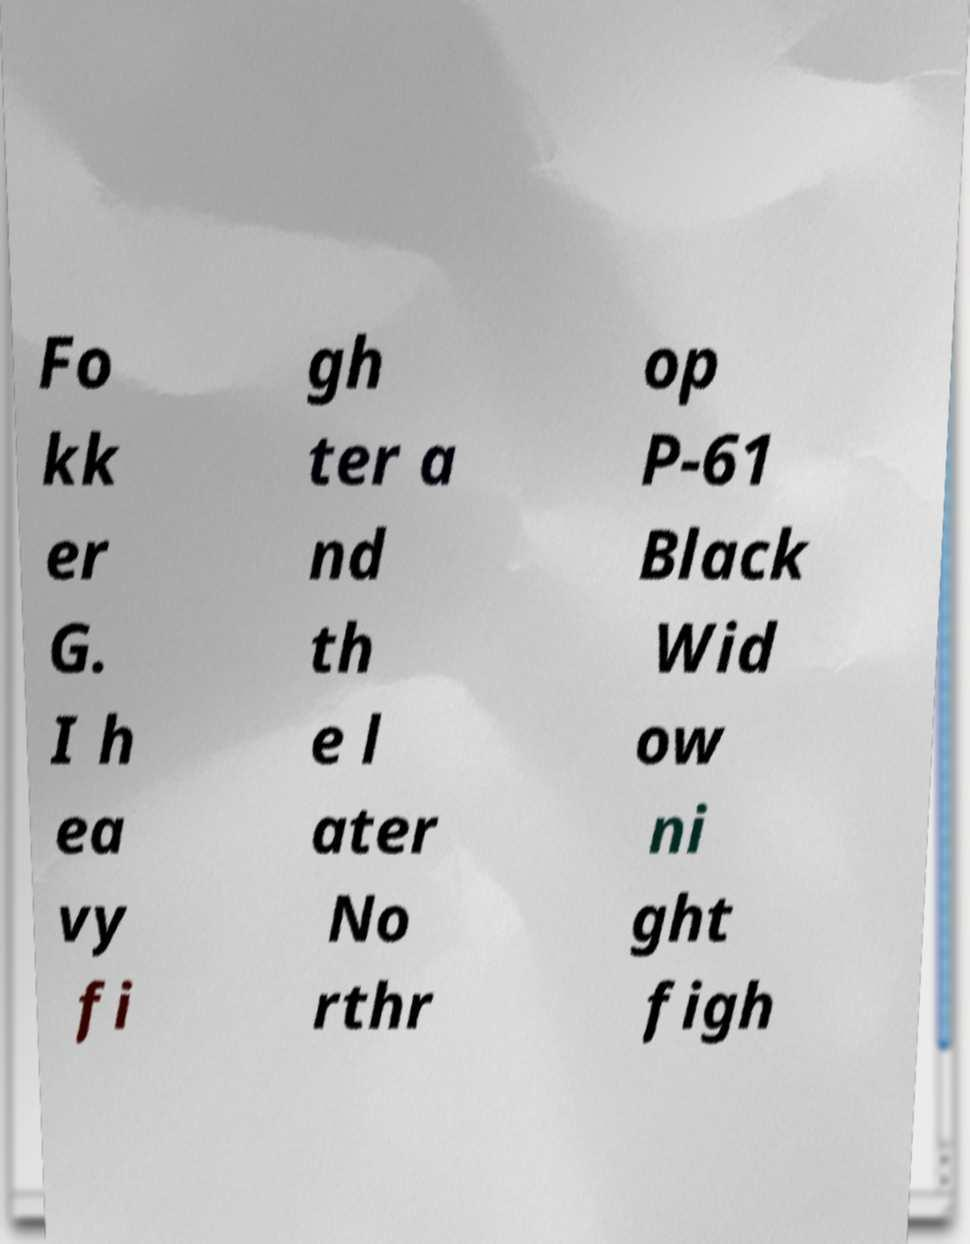Can you read and provide the text displayed in the image?This photo seems to have some interesting text. Can you extract and type it out for me? Fo kk er G. I h ea vy fi gh ter a nd th e l ater No rthr op P-61 Black Wid ow ni ght figh 